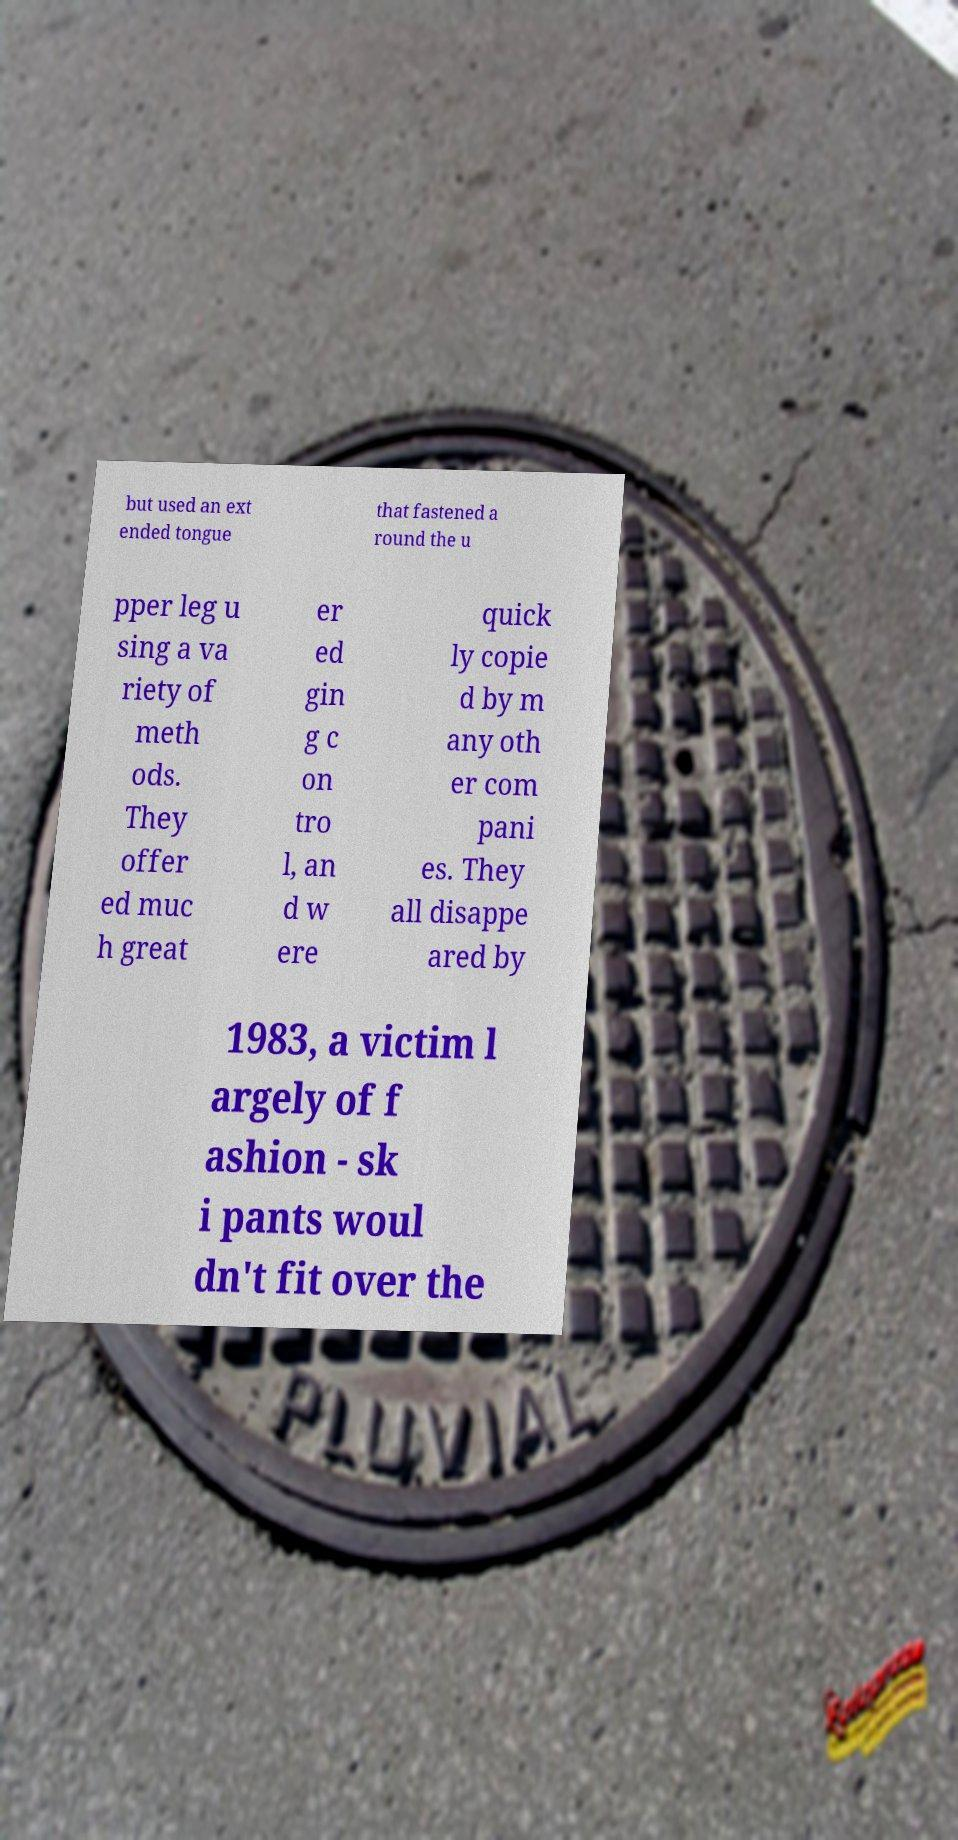For documentation purposes, I need the text within this image transcribed. Could you provide that? but used an ext ended tongue that fastened a round the u pper leg u sing a va riety of meth ods. They offer ed muc h great er ed gin g c on tro l, an d w ere quick ly copie d by m any oth er com pani es. They all disappe ared by 1983, a victim l argely of f ashion - sk i pants woul dn't fit over the 